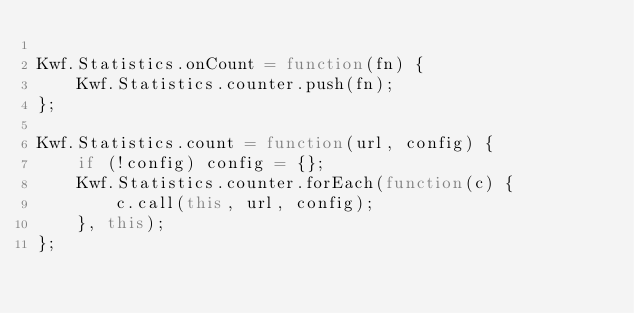Convert code to text. <code><loc_0><loc_0><loc_500><loc_500><_JavaScript_>
Kwf.Statistics.onCount = function(fn) {
    Kwf.Statistics.counter.push(fn);
};

Kwf.Statistics.count = function(url, config) {
    if (!config) config = {};
    Kwf.Statistics.counter.forEach(function(c) {
        c.call(this, url, config);
    }, this);
};
</code> 